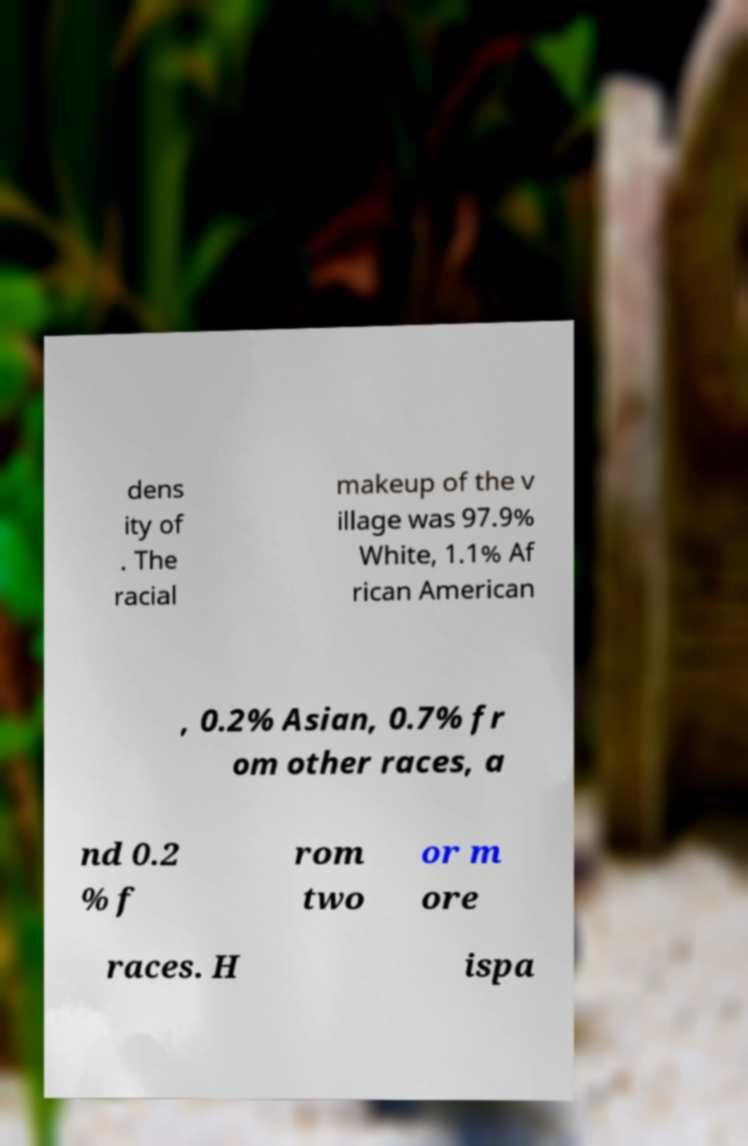There's text embedded in this image that I need extracted. Can you transcribe it verbatim? dens ity of . The racial makeup of the v illage was 97.9% White, 1.1% Af rican American , 0.2% Asian, 0.7% fr om other races, a nd 0.2 % f rom two or m ore races. H ispa 